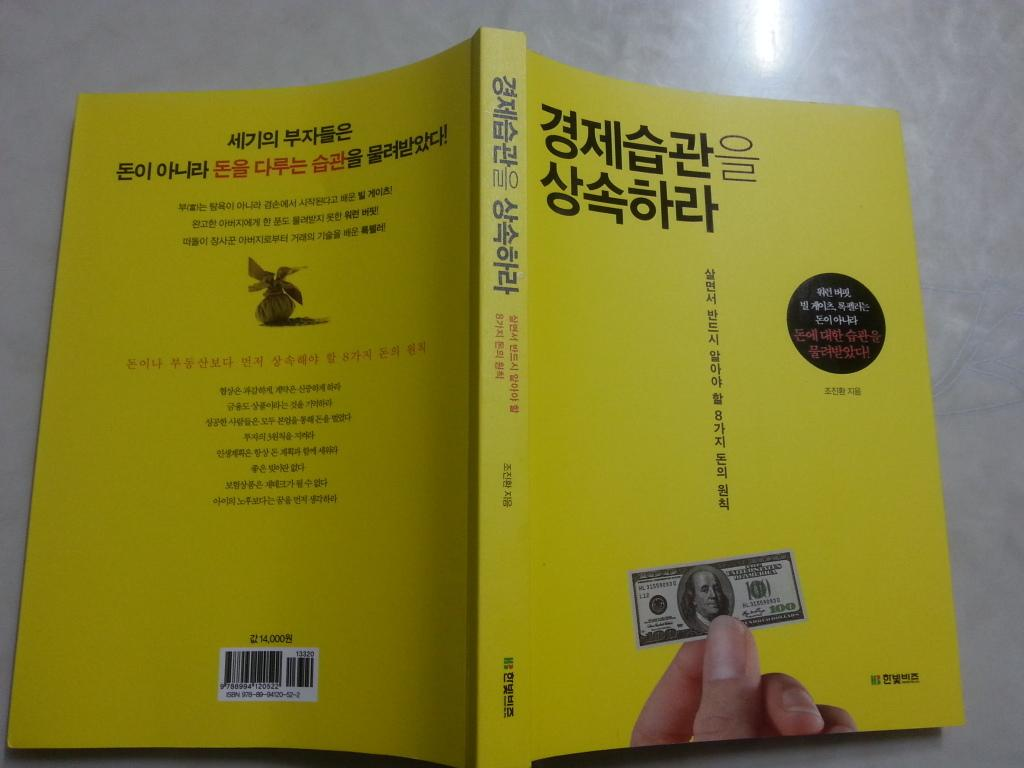Provide a one-sentence caption for the provided image. A book in Chinese shows a picture of a 100 dollar United States Bill on the cover. 